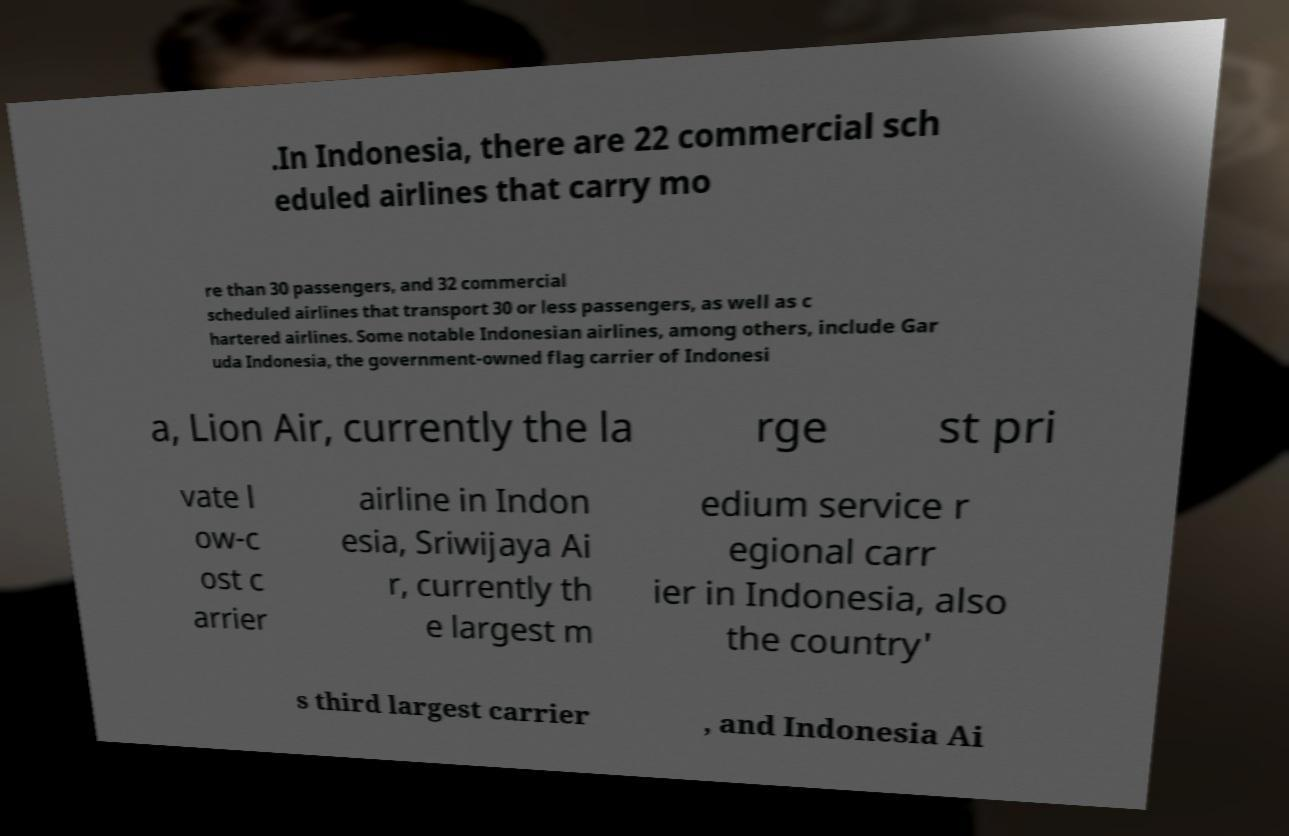Can you accurately transcribe the text from the provided image for me? .In Indonesia, there are 22 commercial sch eduled airlines that carry mo re than 30 passengers, and 32 commercial scheduled airlines that transport 30 or less passengers, as well as c hartered airlines. Some notable Indonesian airlines, among others, include Gar uda Indonesia, the government-owned flag carrier of Indonesi a, Lion Air, currently the la rge st pri vate l ow-c ost c arrier airline in Indon esia, Sriwijaya Ai r, currently th e largest m edium service r egional carr ier in Indonesia, also the country' s third largest carrier , and Indonesia Ai 